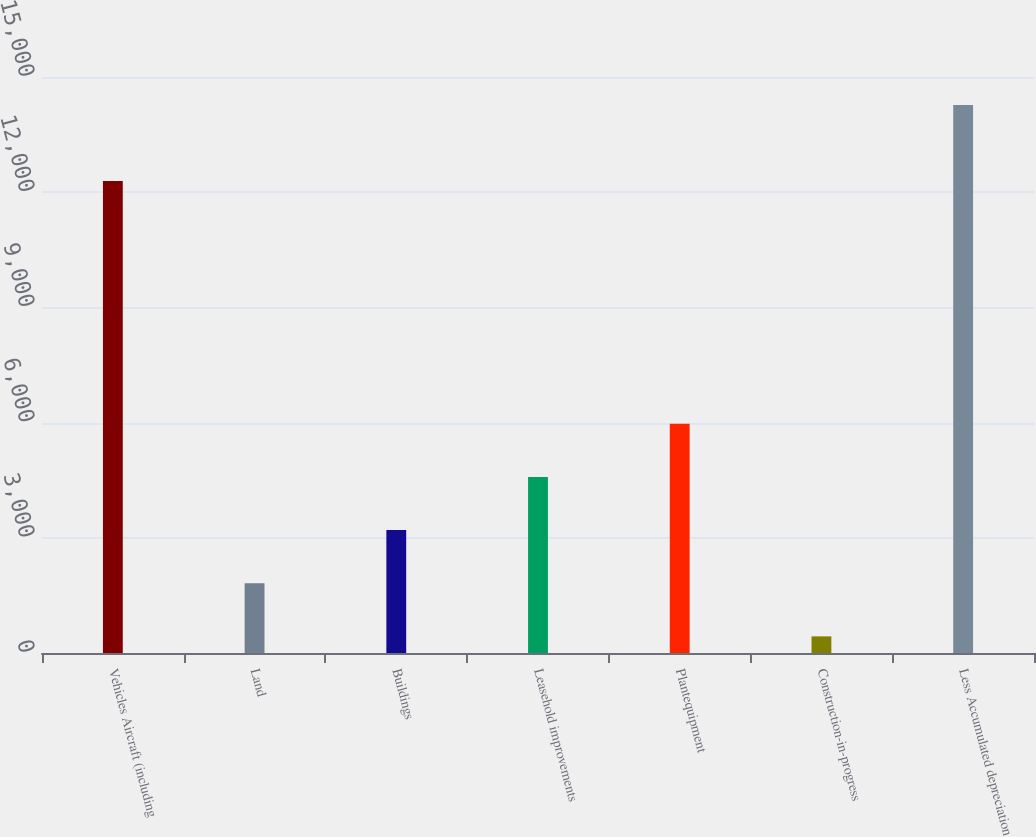Convert chart. <chart><loc_0><loc_0><loc_500><loc_500><bar_chart><fcel>Vehicles Aircraft (including<fcel>Land<fcel>Buildings<fcel>Leasehold improvements<fcel>Plantequipment<fcel>Construction-in-progress<fcel>Less Accumulated depreciation<nl><fcel>12289<fcel>1816.5<fcel>3200<fcel>4583.5<fcel>5967<fcel>433<fcel>14268<nl></chart> 